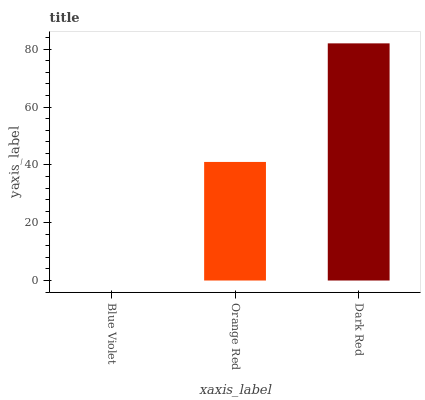Is Blue Violet the minimum?
Answer yes or no. Yes. Is Dark Red the maximum?
Answer yes or no. Yes. Is Orange Red the minimum?
Answer yes or no. No. Is Orange Red the maximum?
Answer yes or no. No. Is Orange Red greater than Blue Violet?
Answer yes or no. Yes. Is Blue Violet less than Orange Red?
Answer yes or no. Yes. Is Blue Violet greater than Orange Red?
Answer yes or no. No. Is Orange Red less than Blue Violet?
Answer yes or no. No. Is Orange Red the high median?
Answer yes or no. Yes. Is Orange Red the low median?
Answer yes or no. Yes. Is Blue Violet the high median?
Answer yes or no. No. Is Dark Red the low median?
Answer yes or no. No. 